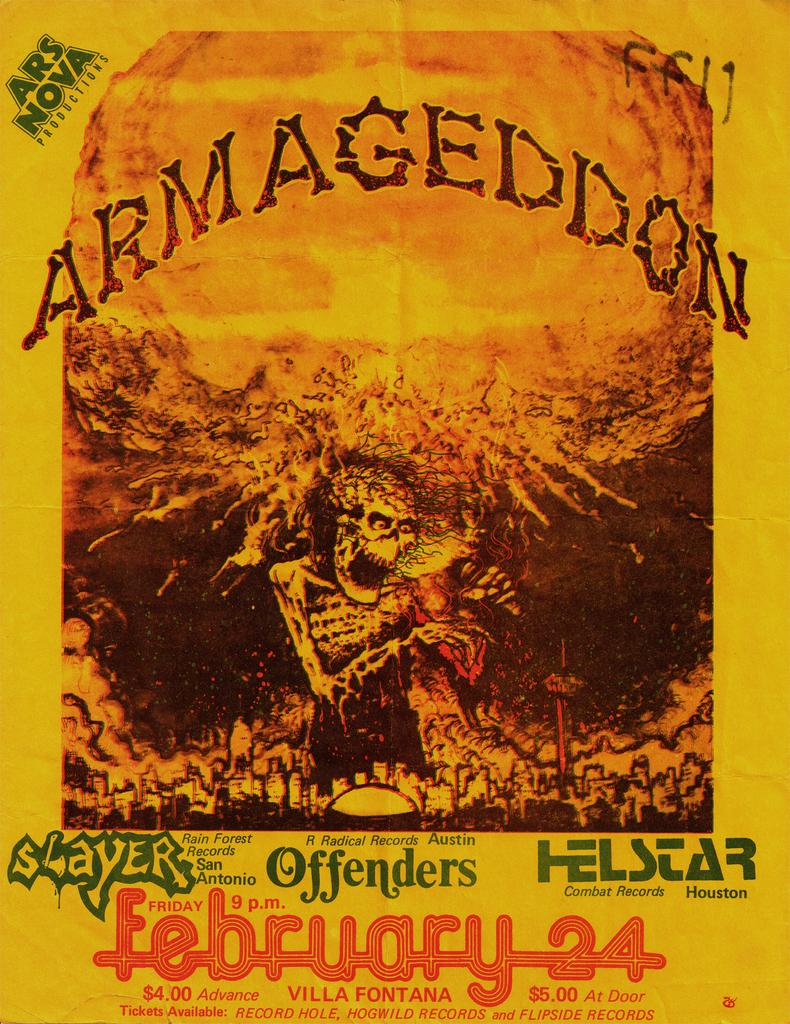<image>
Summarize the visual content of the image. A poster of an advertisement of Armageddon on Friday, February 24 at 9 p.m. 